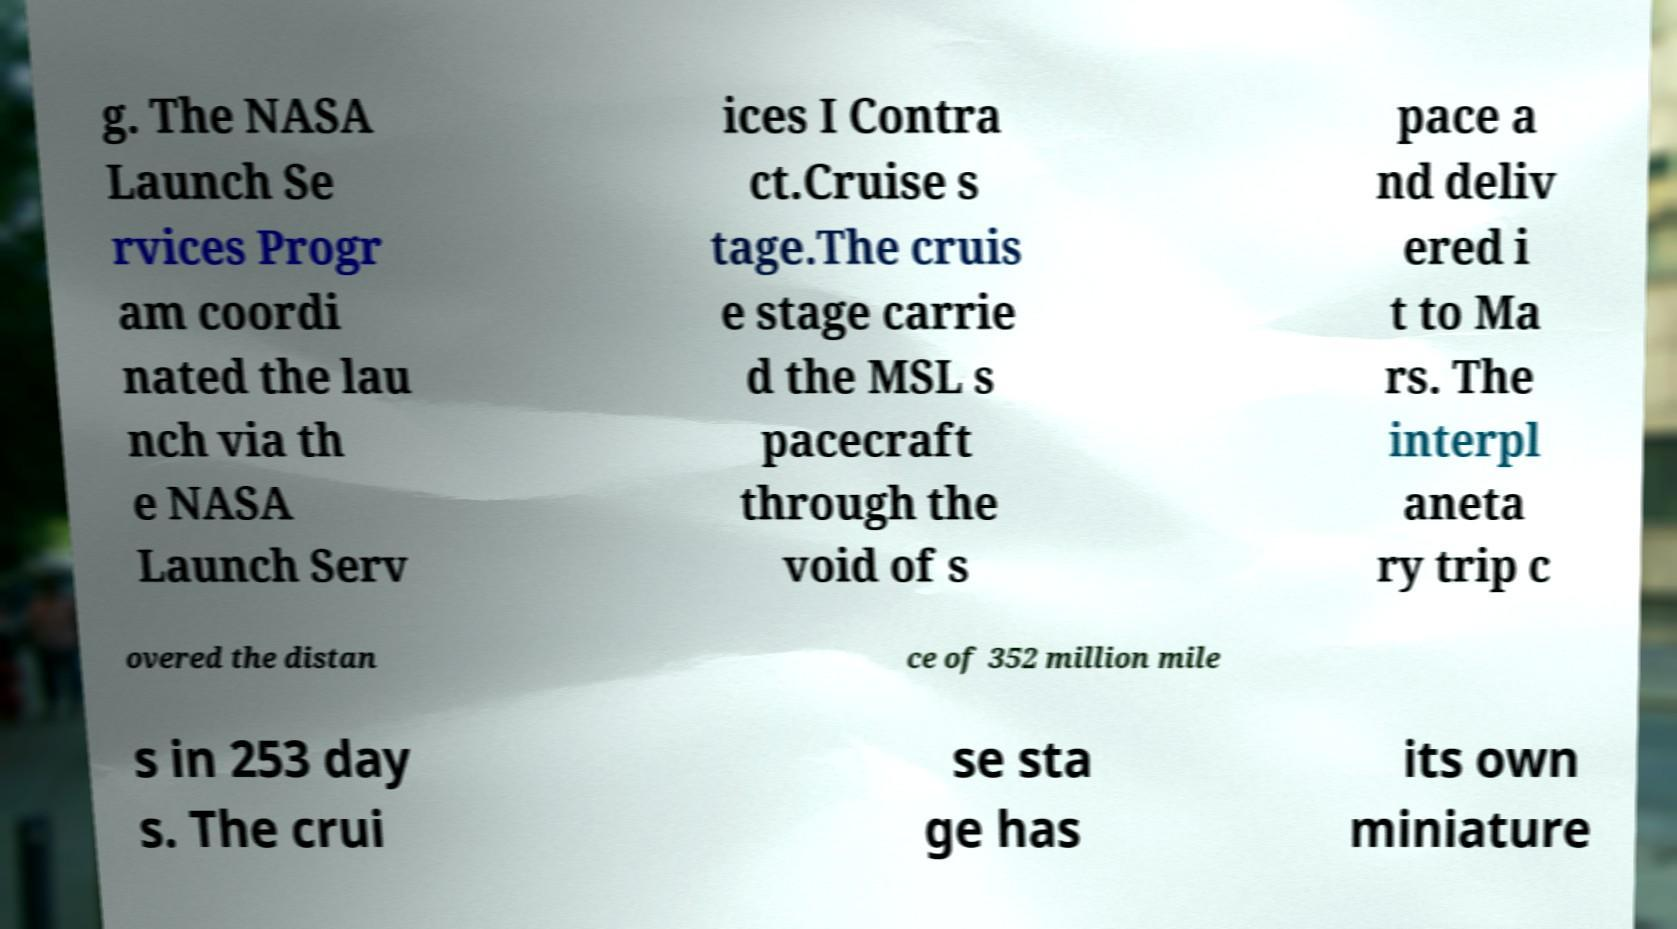What messages or text are displayed in this image? I need them in a readable, typed format. g. The NASA Launch Se rvices Progr am coordi nated the lau nch via th e NASA Launch Serv ices I Contra ct.Cruise s tage.The cruis e stage carrie d the MSL s pacecraft through the void of s pace a nd deliv ered i t to Ma rs. The interpl aneta ry trip c overed the distan ce of 352 million mile s in 253 day s. The crui se sta ge has its own miniature 